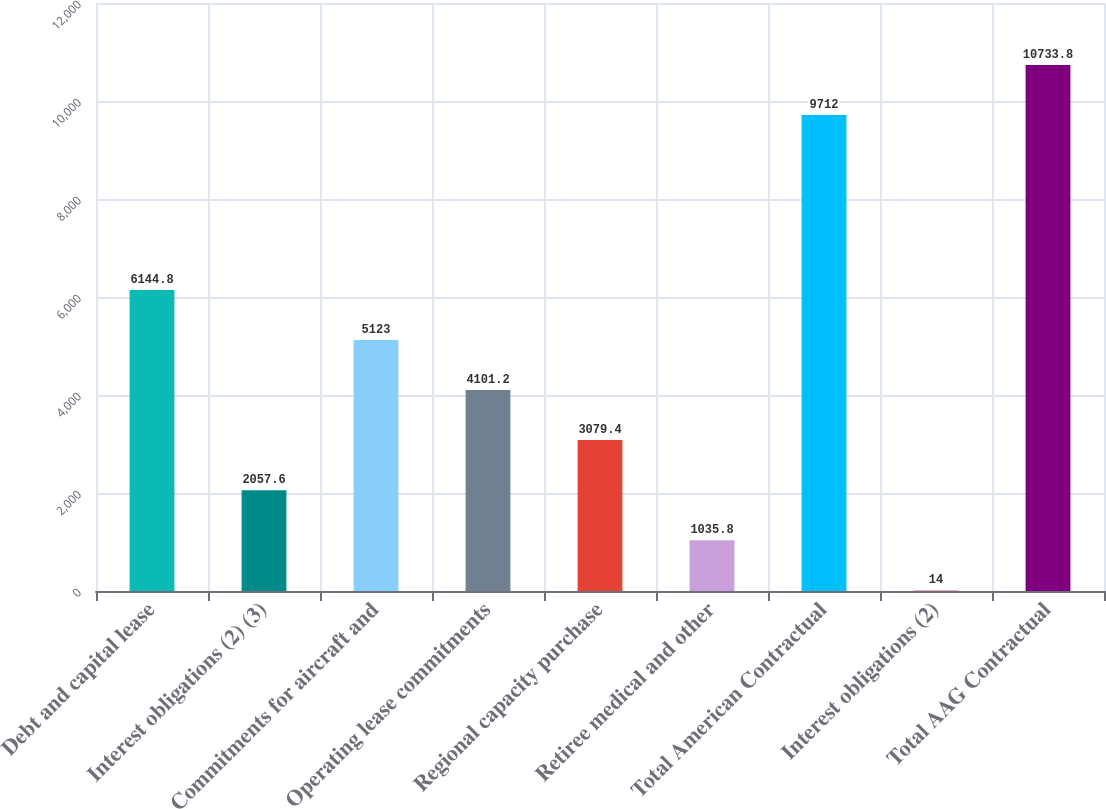Convert chart. <chart><loc_0><loc_0><loc_500><loc_500><bar_chart><fcel>Debt and capital lease<fcel>Interest obligations (2) (3)<fcel>Commitments for aircraft and<fcel>Operating lease commitments<fcel>Regional capacity purchase<fcel>Retiree medical and other<fcel>Total American Contractual<fcel>Interest obligations (2)<fcel>Total AAG Contractual<nl><fcel>6144.8<fcel>2057.6<fcel>5123<fcel>4101.2<fcel>3079.4<fcel>1035.8<fcel>9712<fcel>14<fcel>10733.8<nl></chart> 